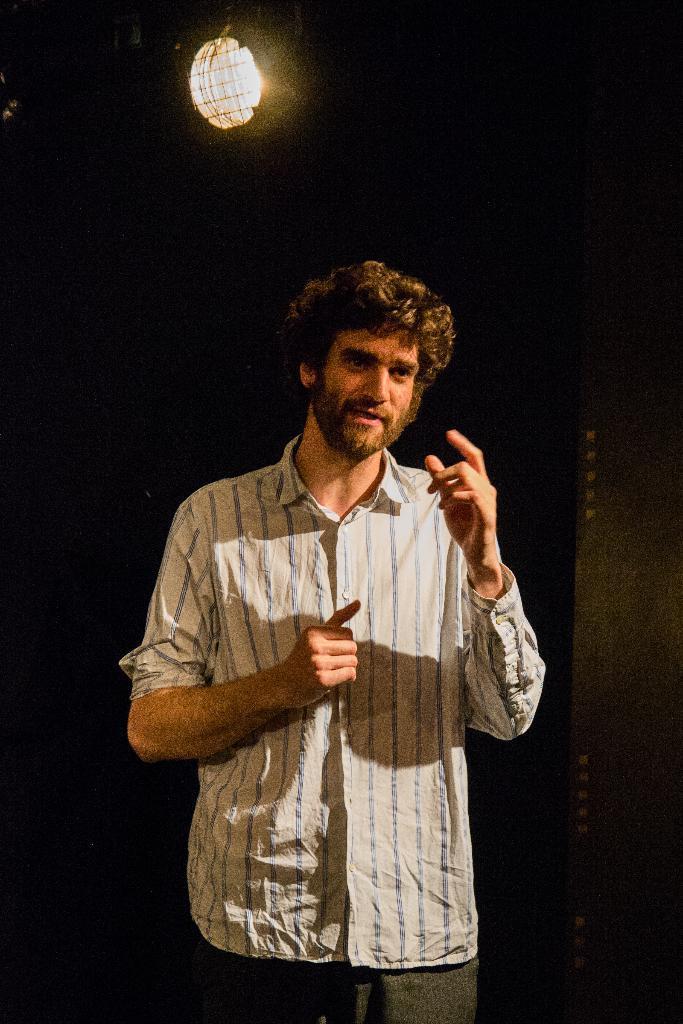How would you summarize this image in a sentence or two? There is a man standing and talking. In the background it is dark and we can see light. 